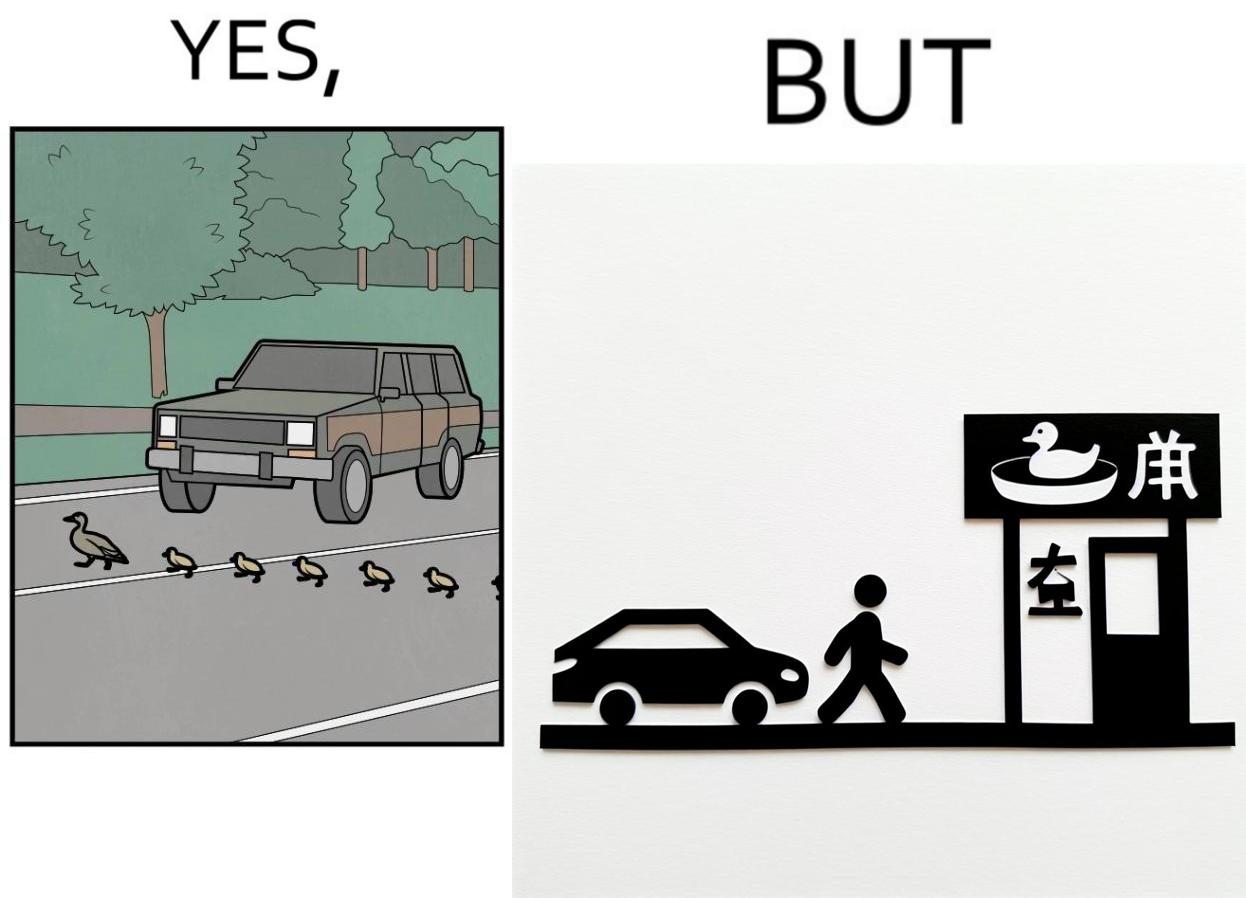Describe what you see in the left and right parts of this image. In the left part of the image: It is a car stopping to give way to queue of ducks crossing the road and allow them to cross safely In the right part of the image: It is a man parking his car and entering a peking duck shop 